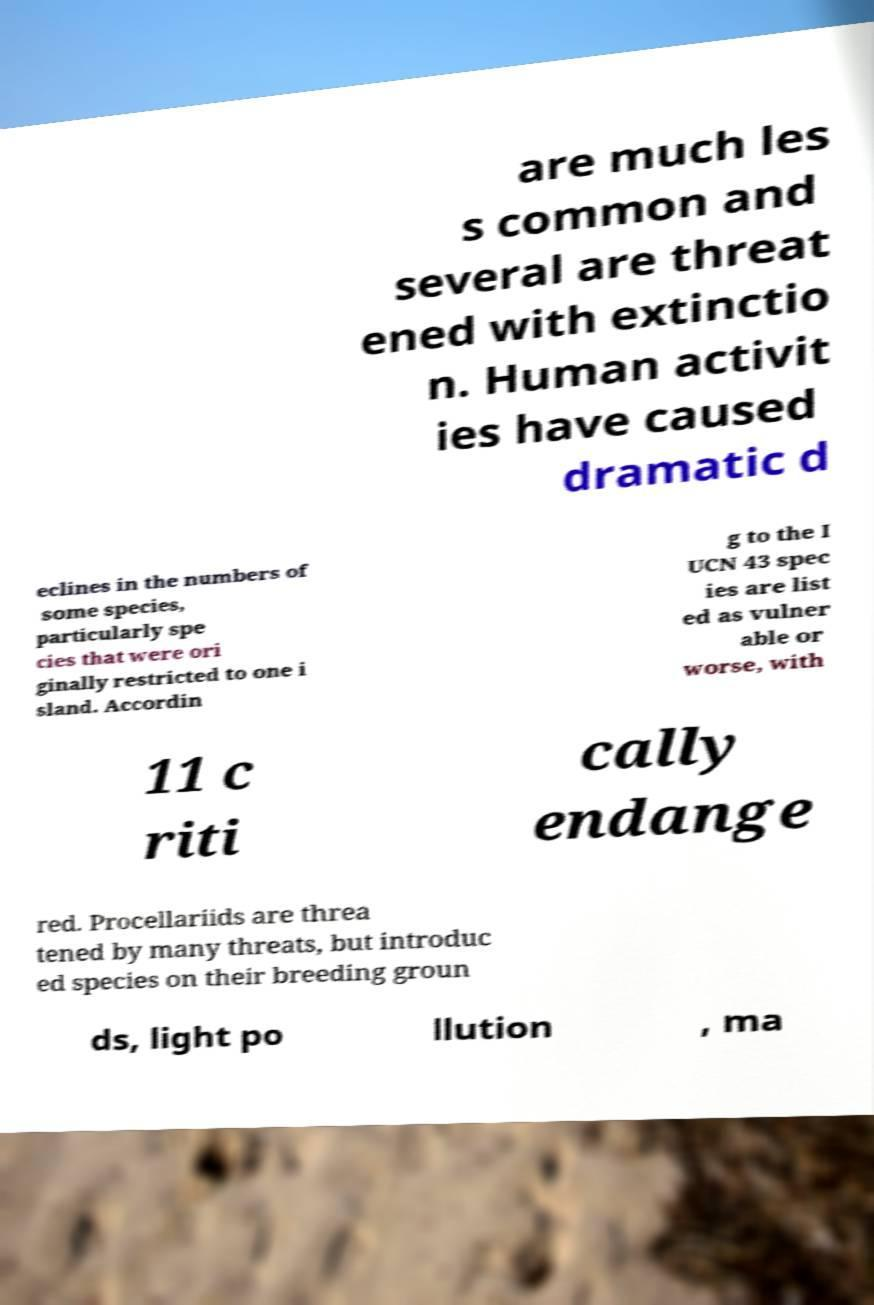For documentation purposes, I need the text within this image transcribed. Could you provide that? are much les s common and several are threat ened with extinctio n. Human activit ies have caused dramatic d eclines in the numbers of some species, particularly spe cies that were ori ginally restricted to one i sland. Accordin g to the I UCN 43 spec ies are list ed as vulner able or worse, with 11 c riti cally endange red. Procellariids are threa tened by many threats, but introduc ed species on their breeding groun ds, light po llution , ma 